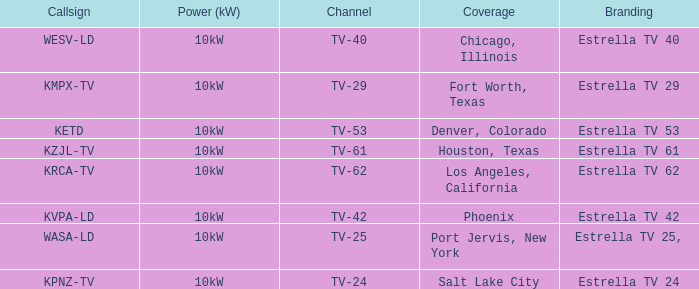List the power output for Phoenix.  10kW. 